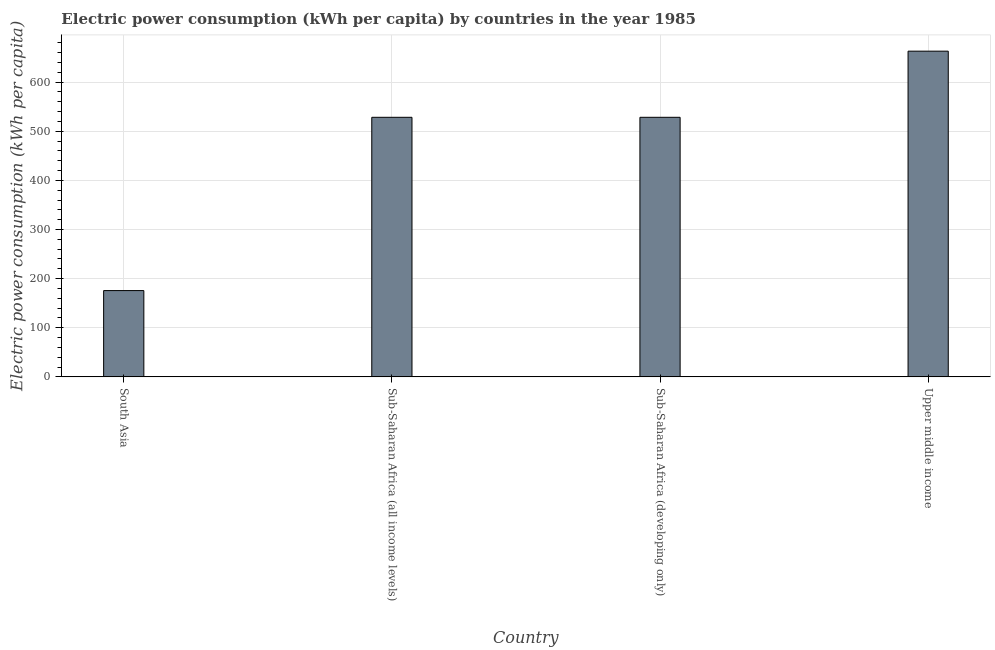Does the graph contain any zero values?
Ensure brevity in your answer.  No. Does the graph contain grids?
Offer a terse response. Yes. What is the title of the graph?
Your answer should be very brief. Electric power consumption (kWh per capita) by countries in the year 1985. What is the label or title of the Y-axis?
Keep it short and to the point. Electric power consumption (kWh per capita). What is the electric power consumption in Sub-Saharan Africa (all income levels)?
Give a very brief answer. 528.41. Across all countries, what is the maximum electric power consumption?
Offer a terse response. 663.04. Across all countries, what is the minimum electric power consumption?
Your answer should be very brief. 175.66. In which country was the electric power consumption maximum?
Offer a very short reply. Upper middle income. What is the sum of the electric power consumption?
Your response must be concise. 1895.51. What is the difference between the electric power consumption in South Asia and Sub-Saharan Africa (all income levels)?
Give a very brief answer. -352.75. What is the average electric power consumption per country?
Offer a terse response. 473.88. What is the median electric power consumption?
Ensure brevity in your answer.  528.41. In how many countries, is the electric power consumption greater than 600 kWh per capita?
Ensure brevity in your answer.  1. What is the ratio of the electric power consumption in South Asia to that in Sub-Saharan Africa (developing only)?
Your answer should be very brief. 0.33. What is the difference between the highest and the second highest electric power consumption?
Offer a terse response. 134.64. What is the difference between the highest and the lowest electric power consumption?
Provide a short and direct response. 487.39. In how many countries, is the electric power consumption greater than the average electric power consumption taken over all countries?
Provide a succinct answer. 3. What is the Electric power consumption (kWh per capita) of South Asia?
Offer a terse response. 175.66. What is the Electric power consumption (kWh per capita) of Sub-Saharan Africa (all income levels)?
Provide a short and direct response. 528.41. What is the Electric power consumption (kWh per capita) of Sub-Saharan Africa (developing only)?
Offer a very short reply. 528.41. What is the Electric power consumption (kWh per capita) in Upper middle income?
Offer a terse response. 663.04. What is the difference between the Electric power consumption (kWh per capita) in South Asia and Sub-Saharan Africa (all income levels)?
Keep it short and to the point. -352.75. What is the difference between the Electric power consumption (kWh per capita) in South Asia and Sub-Saharan Africa (developing only)?
Your answer should be very brief. -352.75. What is the difference between the Electric power consumption (kWh per capita) in South Asia and Upper middle income?
Make the answer very short. -487.39. What is the difference between the Electric power consumption (kWh per capita) in Sub-Saharan Africa (all income levels) and Upper middle income?
Offer a very short reply. -134.64. What is the difference between the Electric power consumption (kWh per capita) in Sub-Saharan Africa (developing only) and Upper middle income?
Make the answer very short. -134.64. What is the ratio of the Electric power consumption (kWh per capita) in South Asia to that in Sub-Saharan Africa (all income levels)?
Provide a short and direct response. 0.33. What is the ratio of the Electric power consumption (kWh per capita) in South Asia to that in Sub-Saharan Africa (developing only)?
Your answer should be very brief. 0.33. What is the ratio of the Electric power consumption (kWh per capita) in South Asia to that in Upper middle income?
Your answer should be very brief. 0.27. What is the ratio of the Electric power consumption (kWh per capita) in Sub-Saharan Africa (all income levels) to that in Sub-Saharan Africa (developing only)?
Your answer should be very brief. 1. What is the ratio of the Electric power consumption (kWh per capita) in Sub-Saharan Africa (all income levels) to that in Upper middle income?
Give a very brief answer. 0.8. What is the ratio of the Electric power consumption (kWh per capita) in Sub-Saharan Africa (developing only) to that in Upper middle income?
Your answer should be compact. 0.8. 